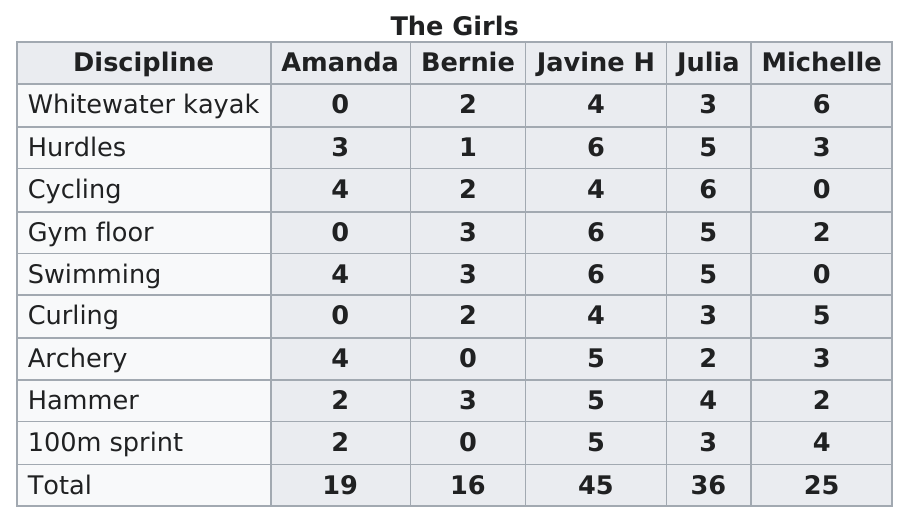Point out several critical features in this image. Julia achieved her best score in cycling. The 100m sprint is the last discipline on the list. The first discipline listed on the chart is whitewater kayaking. Bernard scored 1 point in hurdles. Bernie jumped one hurdle. 